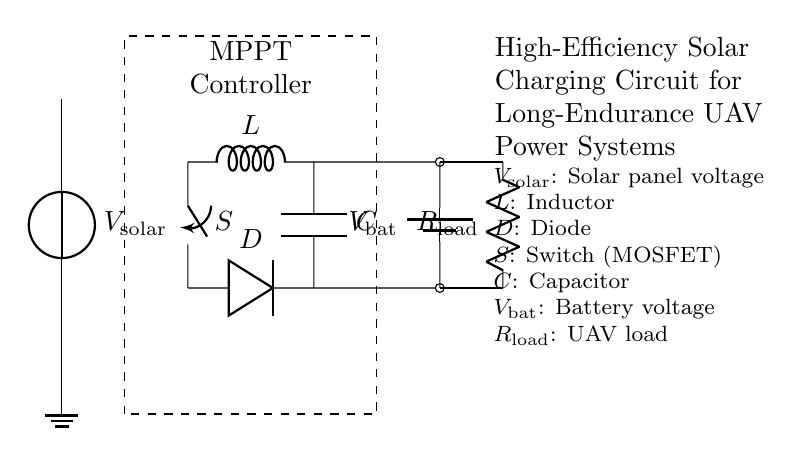What is the type of controller used in the circuit? The circuit uses a Maximum Power Point Tracking controller, which is indicated by the label "MPPT Controller" inside a dashed rectangle. This type of controller optimizes the power output from the solar panel.
Answer: MPPT Controller What component is represented by "V_bat"? The "V_bat" represents the battery in the circuit diagram, which is indicated by its label next to the symbol for a battery.
Answer: Battery How many inductors are in the circuit? There is one inductor in the circuit, which is identified by the label "L" next to the inductor symbol.
Answer: One What is the role of the switch labeled "S"? The switch labeled "S" is a MOSFET switch that controls the flow of current in the circuit by opening and closing the path to the inductor. This helps regulate the output voltage to the battery and load.
Answer: MOSFET switch What component regulates the solar panel voltage? The component that regulates the solar panel voltage is the Maximum Power Point Tracking controller, which adjusts the output voltage to ensure optimal power is harvested from the solar panel under varying conditions.
Answer: MPPT Controller If the load resistance is denoted as "R_load", what type of component is it? "R_load" is represented by the symbol for a resistor in the circuit diagram, denoting that it is a passive electrical component that limits current flow.
Answer: Resistor 